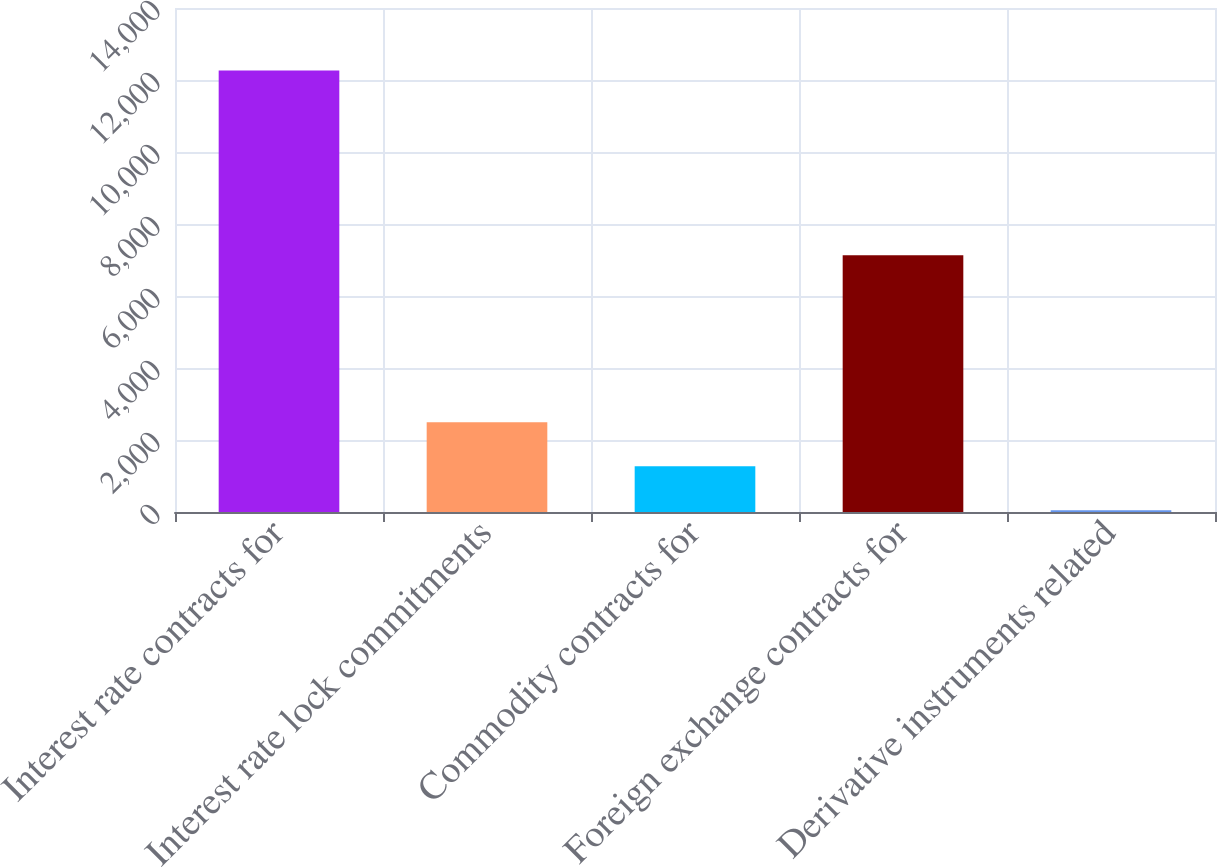<chart> <loc_0><loc_0><loc_500><loc_500><bar_chart><fcel>Interest rate contracts for<fcel>Interest rate lock commitments<fcel>Commodity contracts for<fcel>Foreign exchange contracts for<fcel>Derivative instruments related<nl><fcel>12265<fcel>2493<fcel>1271.5<fcel>7132<fcel>50<nl></chart> 